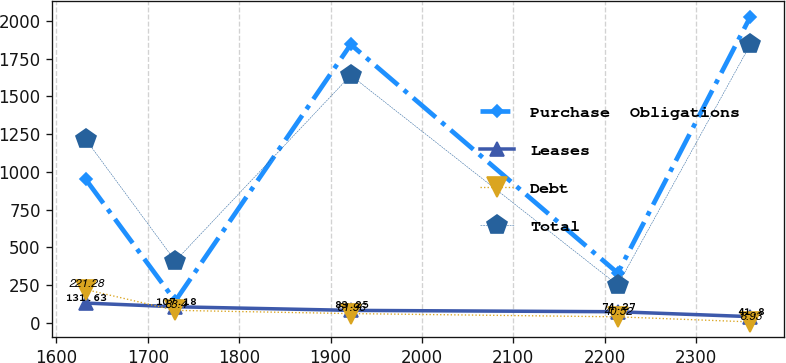<chart> <loc_0><loc_0><loc_500><loc_500><line_chart><ecel><fcel>Purchase  Obligations<fcel>Leases<fcel>Debt<fcel>Total<nl><fcel>1632.08<fcel>951.97<fcel>131.63<fcel>221.28<fcel>1216.46<nl><fcel>1730.16<fcel>145.37<fcel>107.18<fcel>83.4<fcel>410.23<nl><fcel>1922.11<fcel>1844.4<fcel>83.25<fcel>61.96<fcel>1640.45<nl><fcel>2214.3<fcel>330.49<fcel>74.27<fcel>40.52<fcel>250.77<nl><fcel>2359.5<fcel>2029.52<fcel>41.8<fcel>6.93<fcel>1845.4<nl></chart> 